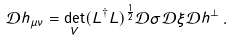<formula> <loc_0><loc_0><loc_500><loc_500>\mathcal { D } h _ { \mu \nu } = \det _ { V } ( L ^ { \dag } L ) ^ { \frac { 1 } { 2 } } \mathcal { D } \sigma \mathcal { D } \xi \mathcal { D } h ^ { \perp } \, .</formula> 